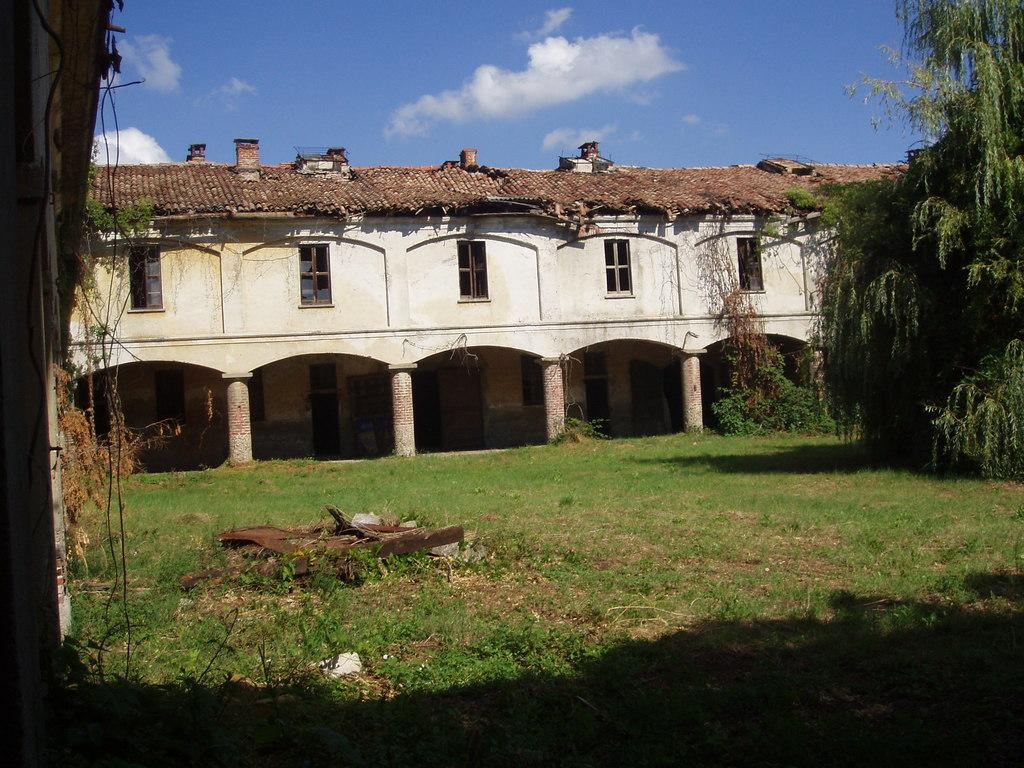What type of structure is visible in the image? There is a building in the image. What type of vegetation can be seen in the image? There are trees in the image. What part of the natural environment is visible in the image? The ground and the sky are visible in the image. What type of plant is present in the image? Creepers are present in the image. What is visible in the sky in the image? Clouds are present in the sky. Where is the badge located in the image? There is no badge present in the image. What type of paste is being used to stick the trees to the ground in the image? There is no paste or any indication of trees being stuck to the ground in the image. 